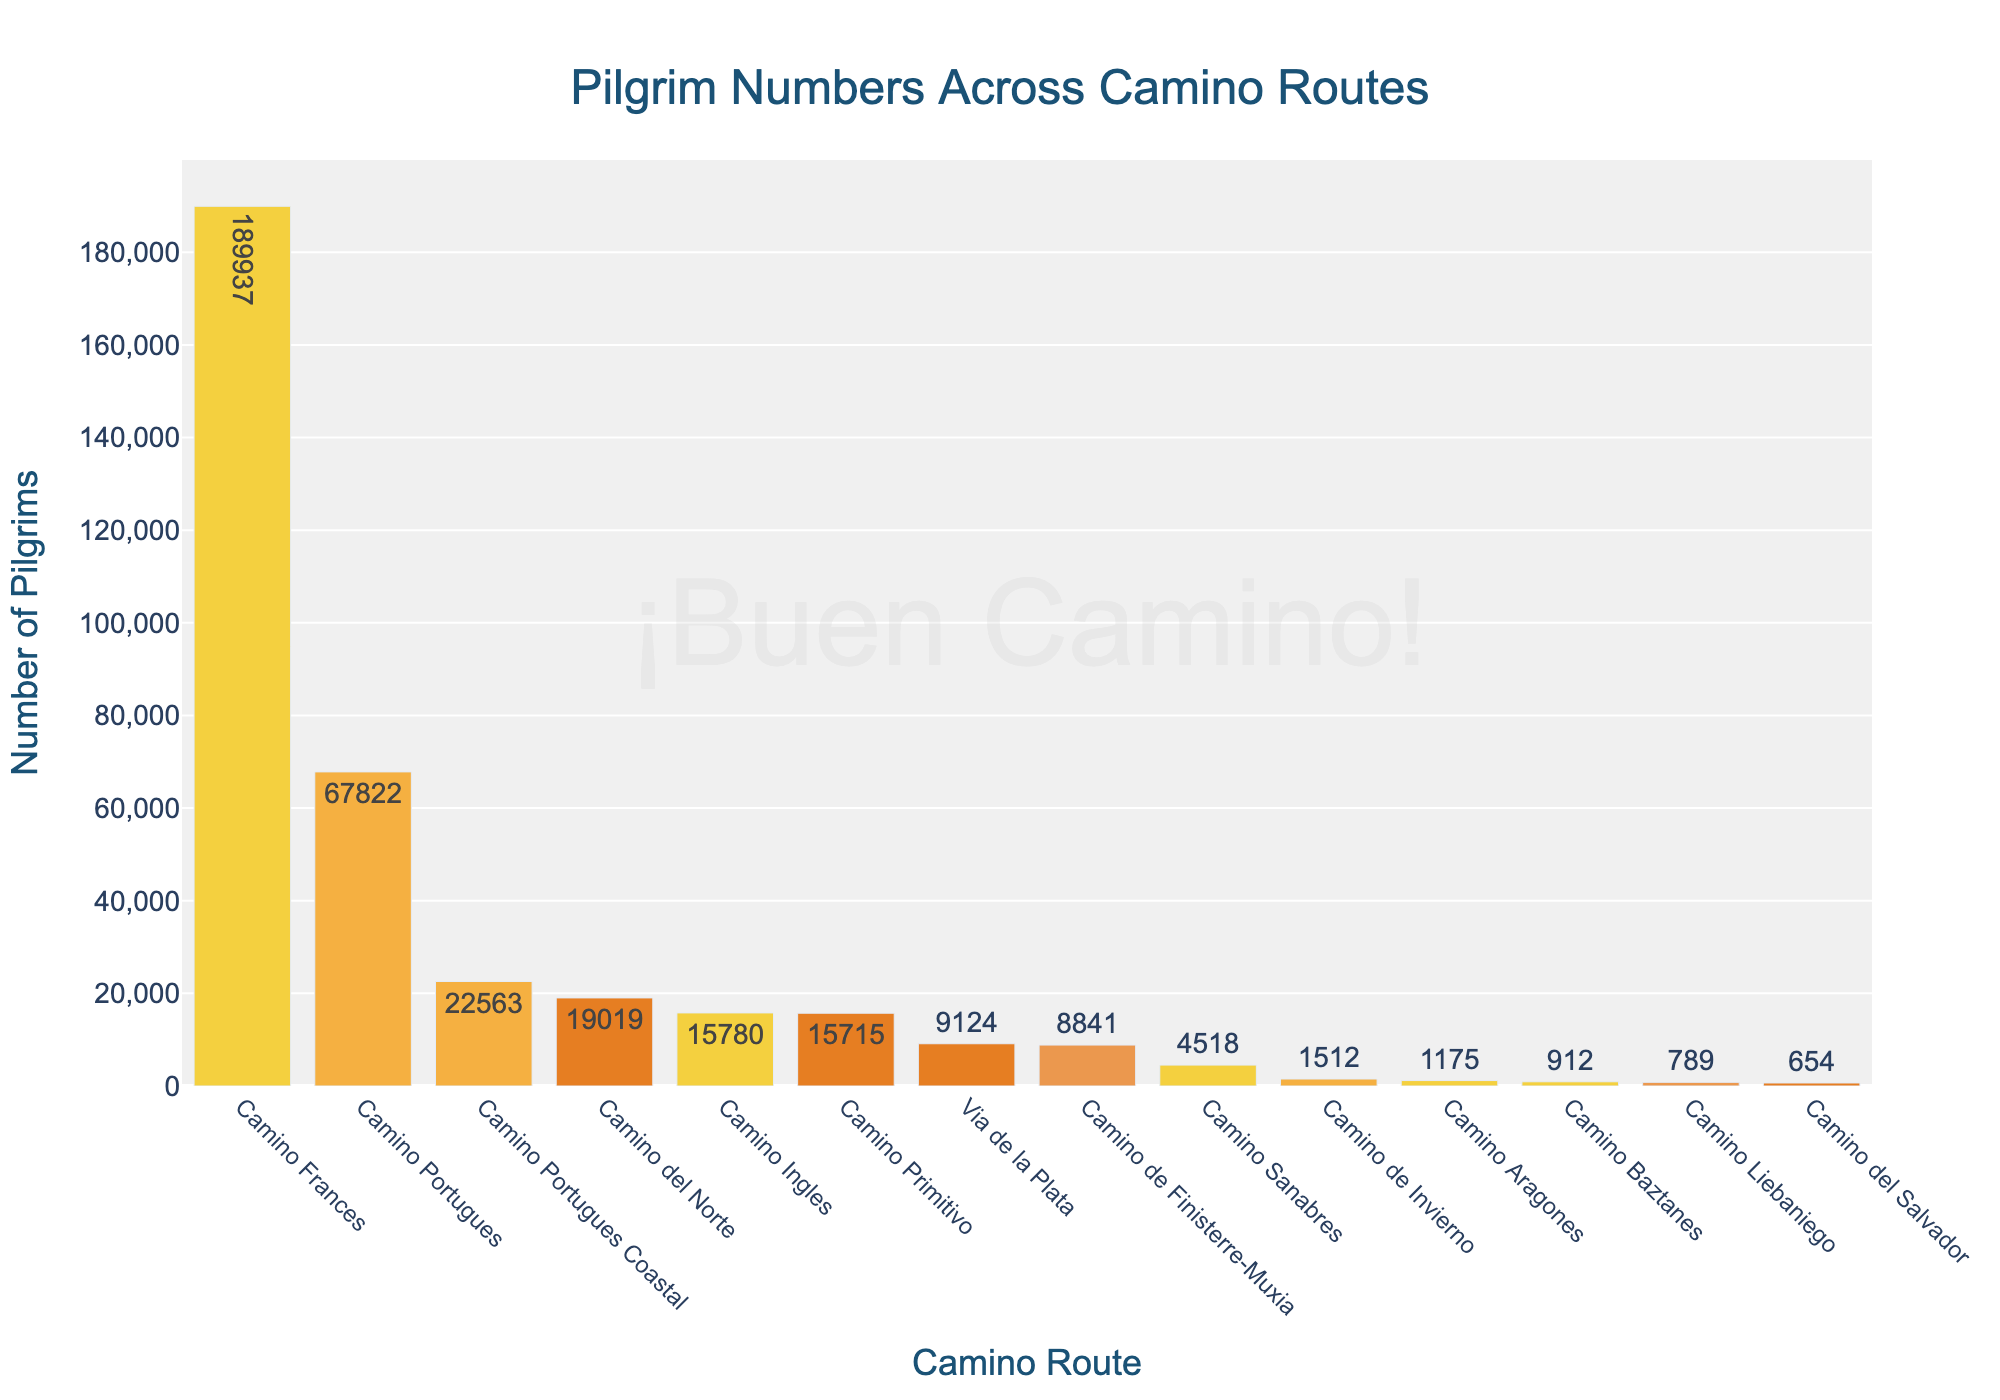Which Camino route has the highest number of pilgrims? To find the route with the highest number of pilgrims, we look for the tallest bar in the chart, which represents the Camino with the most pilgrims.
Answer: Camino Frances How many more pilgrims traveled the Camino Frances compared to the Camino del Norte? To find the difference, subtract the number of pilgrims of the Camino del Norte from the number of pilgrims of the Camino Frances. \[ 189,937 (Camino Frances) - 19,019 (Camino del Norte) = 170,918 \]
Answer: 170,918 What is the combined number of pilgrims for the Camino Portugues and Camino Portugues Coastal routes? To find the combined number, add the number of pilgrims for the Camino Portugues and the Camino Portugues Coastal routes. \[ 67,822 (Camino Portugues) + 22,563 (Camino Portugues Coastal) = 90,385 \]
Answer: 90,385 How does the number of pilgrims for the Camino Ingles compare to the Camino Primitivo? To compare the number of pilgrims for these two routes, we directly compare their associated values. The Camino Ingles has 15,780 pilgrims and the Camino Primitivo has 15,715 pilgrims.
Answer: Camino Ingles has more Are there any routes with fewer than 1,000 pilgrims? To identify routes with fewer than 1,000 pilgrims, look for bars that extend below the 1,000 pilgrim mark on the y-axis. The Camino Liebaniego, Camino del Salvador, and Camino Baztanes are below this mark.
Answer: Yes What is the average number of pilgrims across all listed routes? To find the average, sum the total number of pilgrims across all routes and divide by the number of routes. The total is obtained by adding each route's pilgrims. \[ (189,937 + 67,822 + 22,563 + 19,019 + 15,715 + 15,780 + 9,124 + 8,841 + 1,512 + 4,518 + 1,175 + 912 + 789 + 654) / 14 = 358,361 / 14 = 25,597.21 \]
Answer: 25,597.21 Which routes have a number of pilgrims closest to the median value? To find the routes closest to the median, list the number of pilgrims in ascending order and find the middle value. The median is calculated as follows: \[ (15,715 + 15,780) / 2 = 15,747.5 \] The routes closest to this value are Camino Ingles (15,780) and Camino Primitivo (15,715).
Answer: Camino Ingles and Camino Primitivo By how much do the pilgrim numbers for Camino de Invierno and Camino Sanabres differ? Subtract the number of pilgrims for Camino Sanabres from Camino de Invierno. \[ 4,518 (Camino Sanabres) - 1,512 (Camino de Invierno) = 3,006 \]
Answer: 3,006 What is the sum of the number of pilgrims for the four least traveled routes? Add the numbers of pilgrims for Camino Baztanes, Camino Liebaniego, Camino del Salvador, and Camino Aragones. \[ 912 (Camino Baztanes) + 789 (Camino Liebaniego) + 654 (Camino del Salvador) + 1,175 (Camino Aragones) = 3,530 \]
Answer: 3,530 